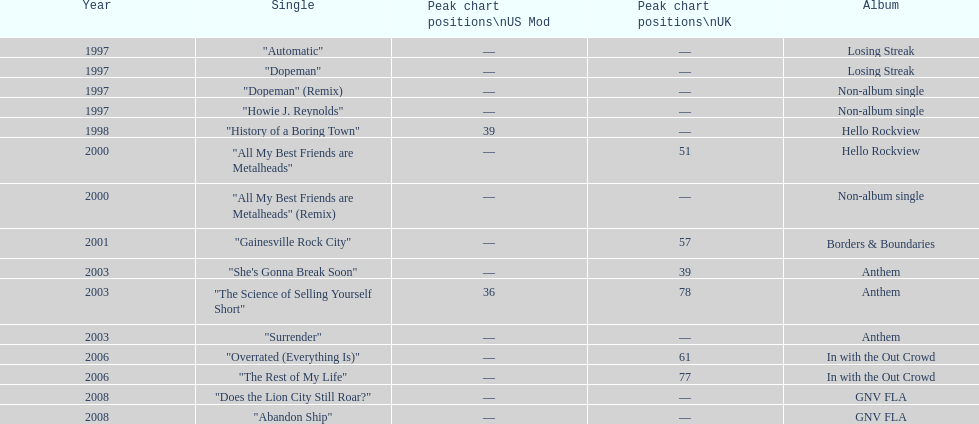Compare the chart positions between the us and the uk for the science of selling yourself short, where did it do better? US. 